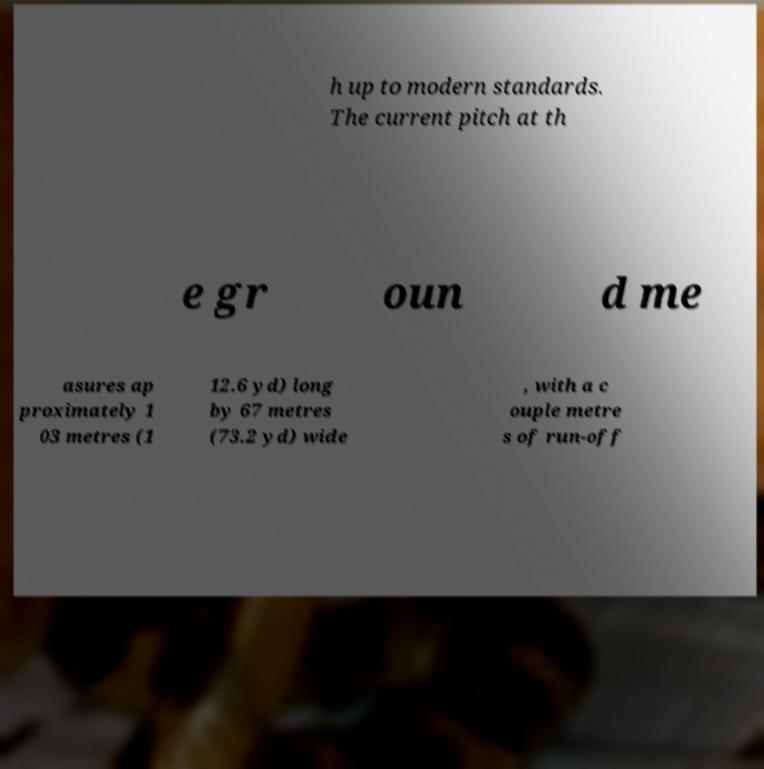What messages or text are displayed in this image? I need them in a readable, typed format. h up to modern standards. The current pitch at th e gr oun d me asures ap proximately 1 03 metres (1 12.6 yd) long by 67 metres (73.2 yd) wide , with a c ouple metre s of run-off 